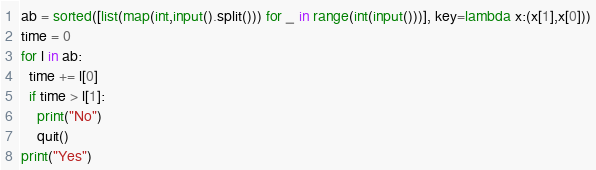<code> <loc_0><loc_0><loc_500><loc_500><_Python_>ab = sorted([list(map(int,input().split())) for _ in range(int(input()))], key=lambda x:(x[1],x[0]))
time = 0
for l in ab:
  time += l[0]
  if time > l[1]:
    print("No")
    quit()
print("Yes")</code> 